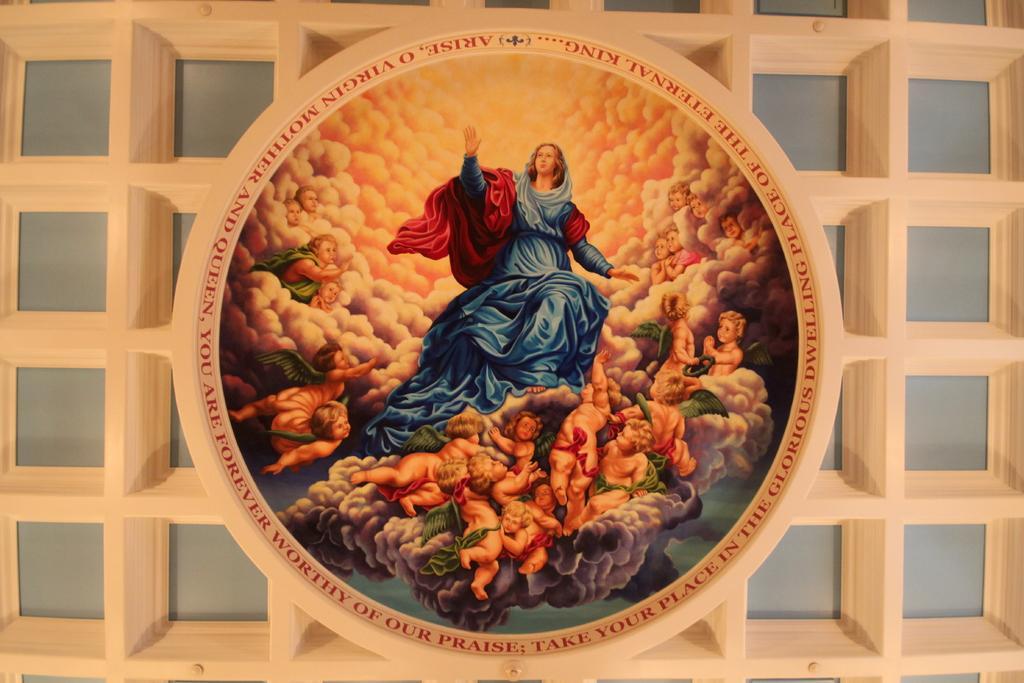In one or two sentences, can you explain what this image depicts? In the center of this picture we can see an object containing the pictures of group of people and the pictures of many other items and we can see the picture of a person wearing blue color dress and seems to be sitting. In the background we can see the object which seems to be the wall. 